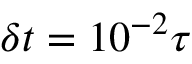<formula> <loc_0><loc_0><loc_500><loc_500>\delta t = 1 0 ^ { - 2 } \tau</formula> 